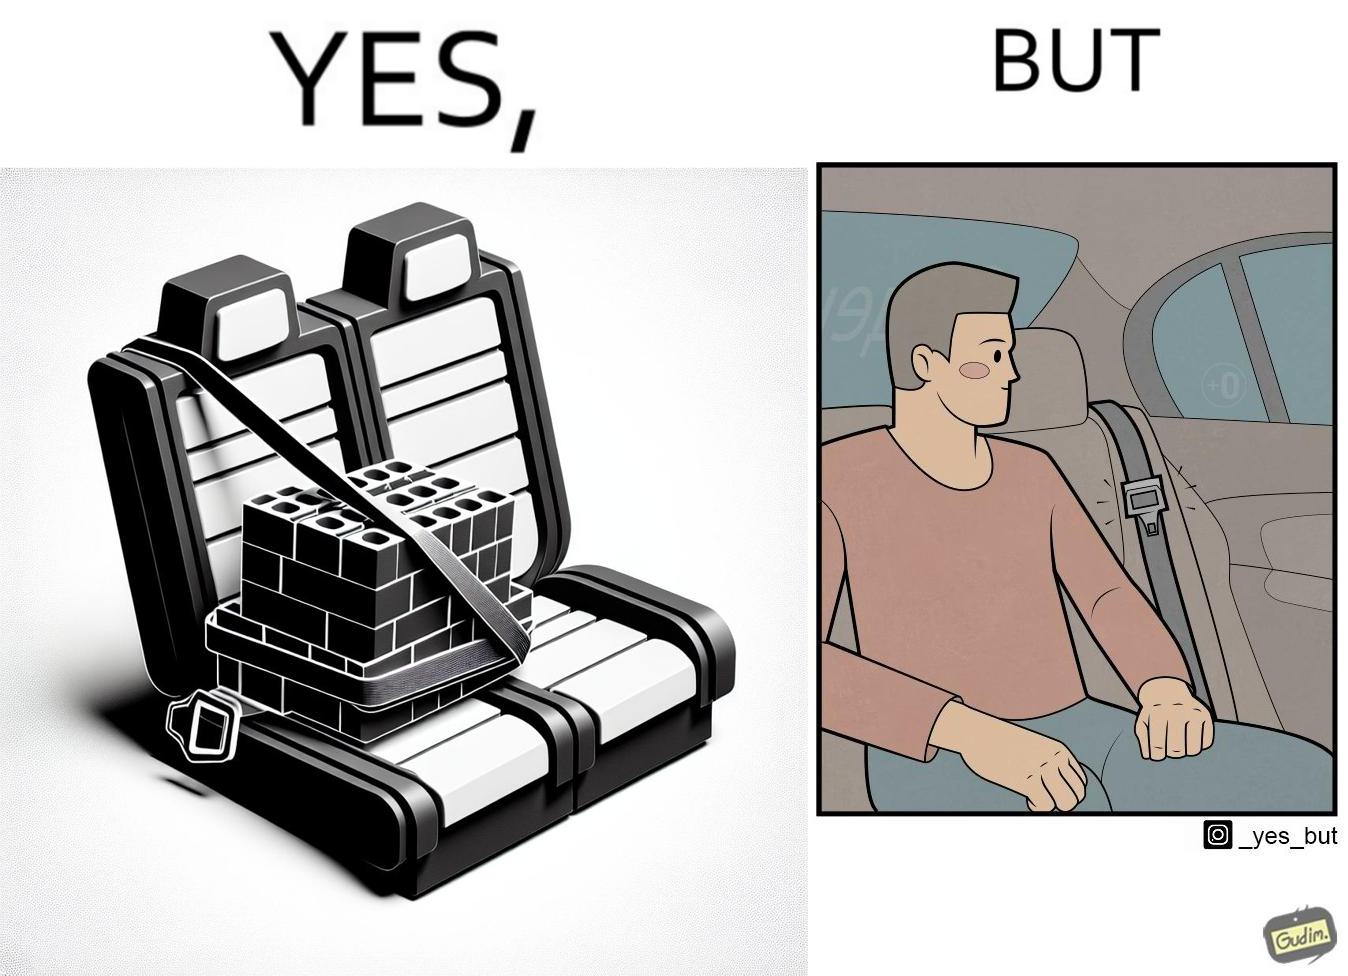Describe what you see in this image. The image is ironical, as an inanimate box of building blocks has been secured by the seatbelt in the backseat of a car, while a person sitting in the backseat is not wearing the seatbelt, while the person would actually need the seatbelt in case there is an accident. 